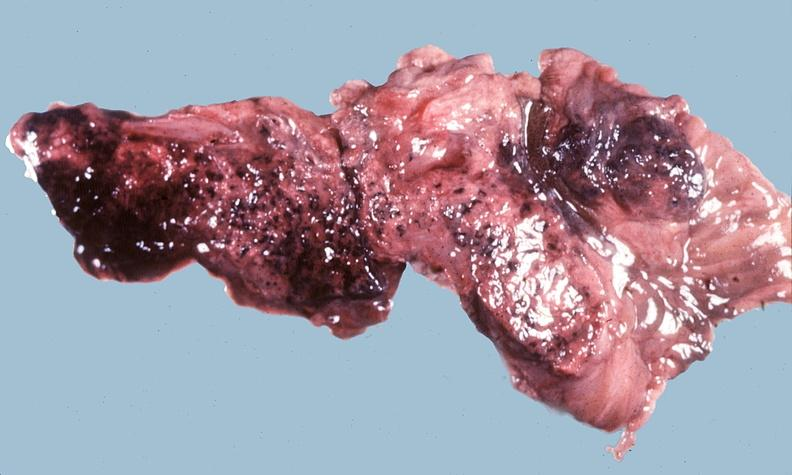does this image show acute hemorrhagic pancreatitis?
Answer the question using a single word or phrase. Yes 